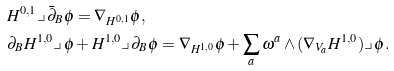<formula> <loc_0><loc_0><loc_500><loc_500>& H ^ { 0 , 1 } \lrcorner \, \bar { \partial } _ { B } \phi = \nabla _ { H ^ { 0 , 1 } } \phi , \\ & \partial _ { B } H ^ { 1 , 0 } \lrcorner \, \phi + H ^ { 1 , 0 } \lrcorner \, \partial _ { B } \phi = \nabla _ { H ^ { 1 , 0 } } \phi + \sum _ { a } \omega ^ { a } \wedge ( \nabla _ { V _ { a } } H ^ { 1 , 0 } ) \lrcorner \, \phi .</formula> 